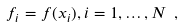<formula> <loc_0><loc_0><loc_500><loc_500>f _ { i } = f ( x _ { i } ) , i = 1 , \dots , N \ ,</formula> 